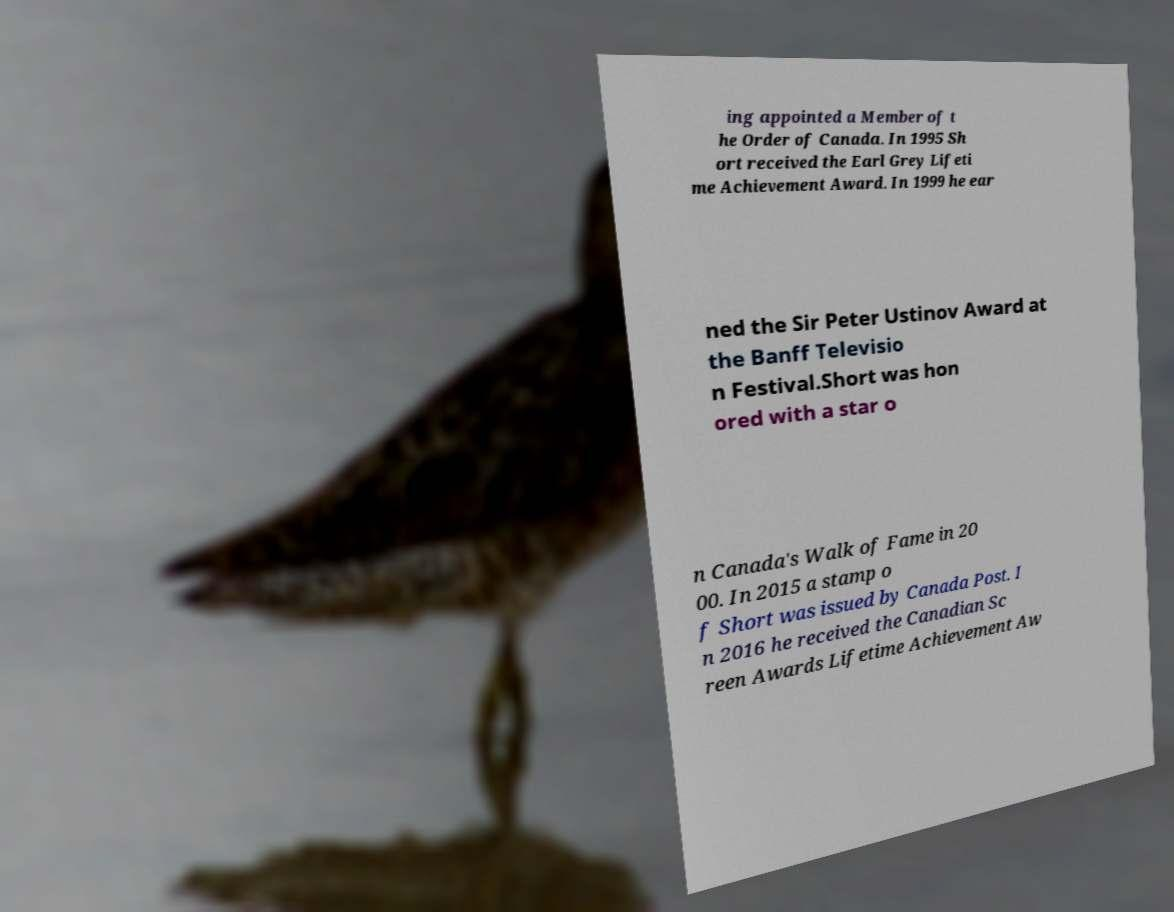I need the written content from this picture converted into text. Can you do that? ing appointed a Member of t he Order of Canada. In 1995 Sh ort received the Earl Grey Lifeti me Achievement Award. In 1999 he ear ned the Sir Peter Ustinov Award at the Banff Televisio n Festival.Short was hon ored with a star o n Canada's Walk of Fame in 20 00. In 2015 a stamp o f Short was issued by Canada Post. I n 2016 he received the Canadian Sc reen Awards Lifetime Achievement Aw 